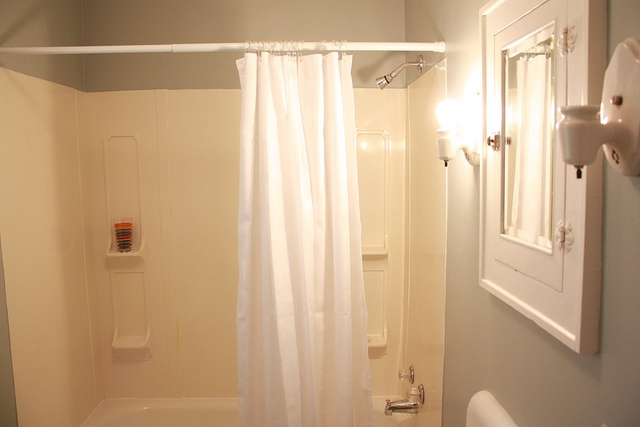Describe the objects in this image and their specific colors. I can see a cup in gray, maroon, brown, and tan tones in this image. 